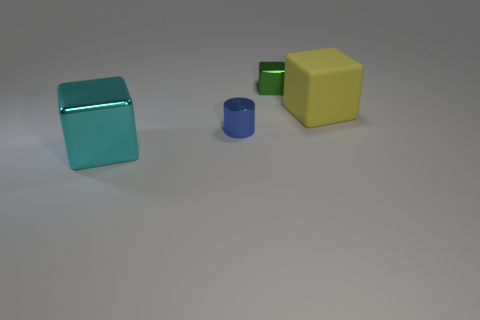Add 2 blue shiny cylinders. How many objects exist? 6 Subtract all blocks. How many objects are left? 1 Add 2 big purple balls. How many big purple balls exist? 2 Subtract 0 green spheres. How many objects are left? 4 Subtract all large brown matte cubes. Subtract all yellow cubes. How many objects are left? 3 Add 4 tiny metallic blocks. How many tiny metallic blocks are left? 5 